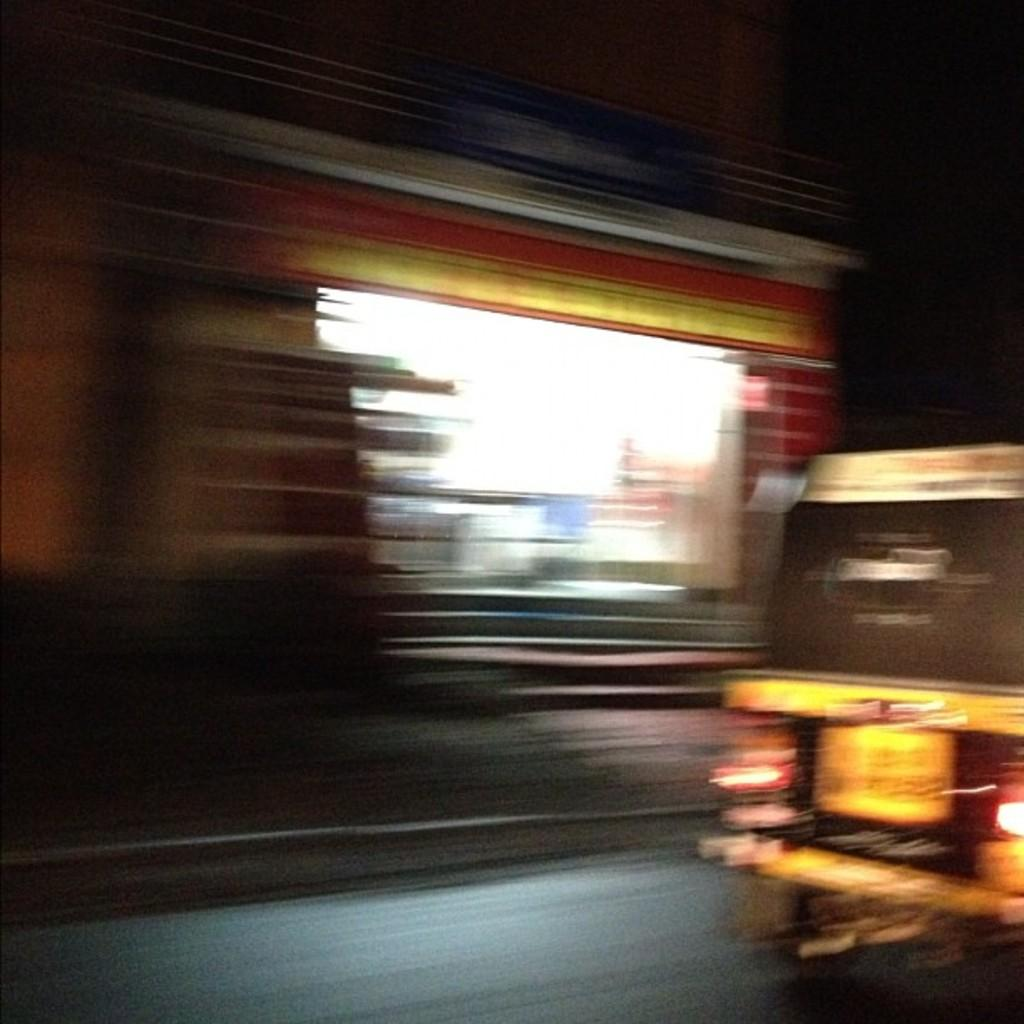What type of vehicle is on the right side of the image? There is an auto rickshaw on the right side of the image. What can be seen in the distance behind the auto rickshaw? There is a building in the background of the image. How would you describe the appearance of the background? The background appears blurry. What type of sky is visible in the image? The provided facts do not mention the sky, so it cannot be determined from the information given. 